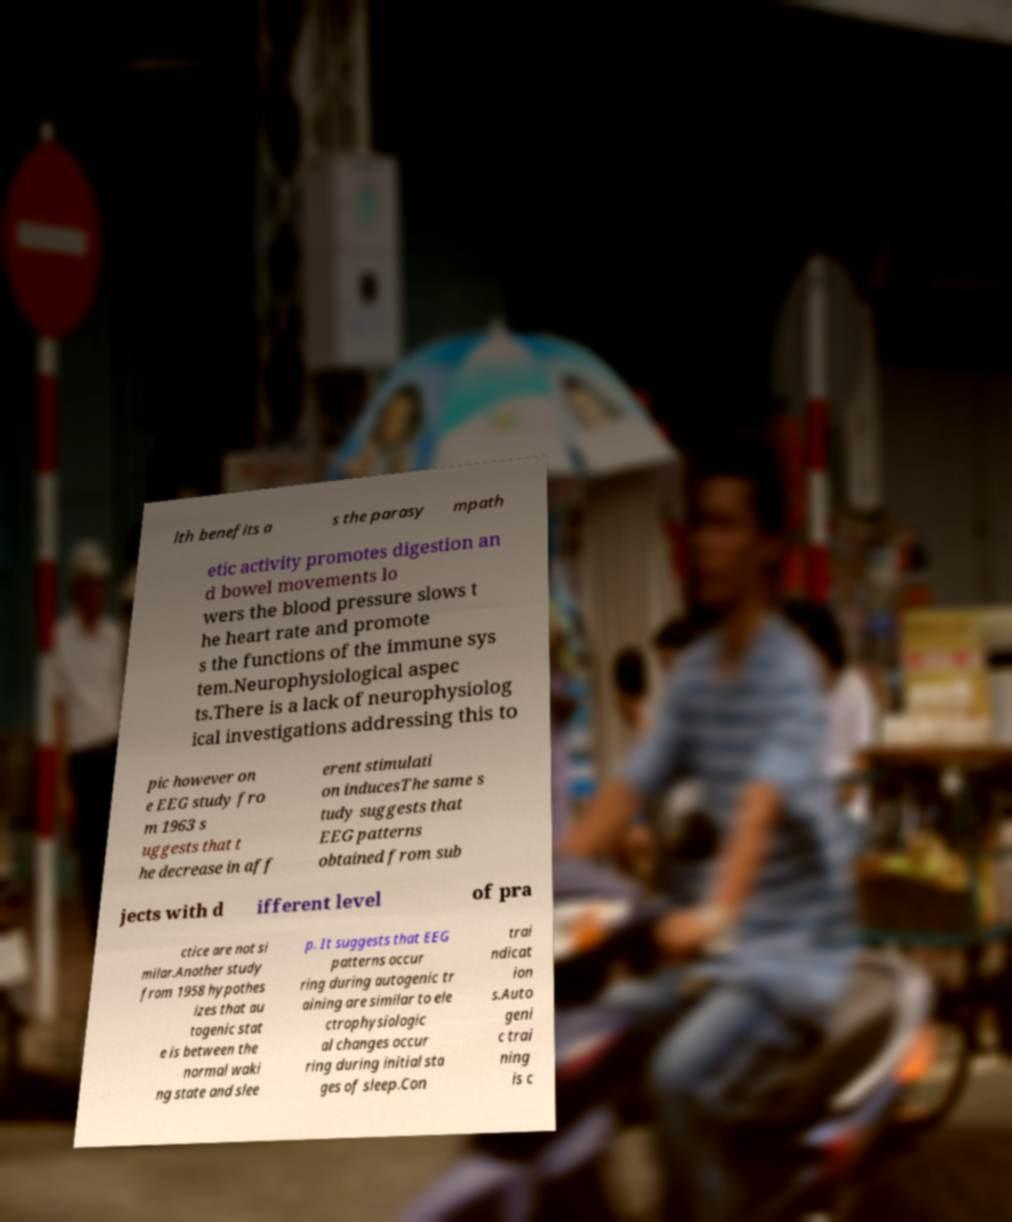For documentation purposes, I need the text within this image transcribed. Could you provide that? lth benefits a s the parasy mpath etic activity promotes digestion an d bowel movements lo wers the blood pressure slows t he heart rate and promote s the functions of the immune sys tem.Neurophysiological aspec ts.There is a lack of neurophysiolog ical investigations addressing this to pic however on e EEG study fro m 1963 s uggests that t he decrease in aff erent stimulati on inducesThe same s tudy suggests that EEG patterns obtained from sub jects with d ifferent level of pra ctice are not si milar.Another study from 1958 hypothes izes that au togenic stat e is between the normal waki ng state and slee p. It suggests that EEG patterns occur ring during autogenic tr aining are similar to ele ctrophysiologic al changes occur ring during initial sta ges of sleep.Con trai ndicat ion s.Auto geni c trai ning is c 